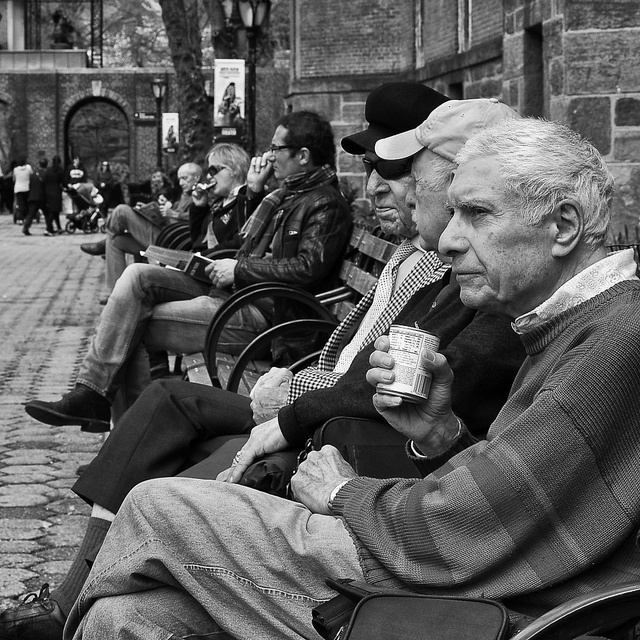Describe the objects in this image and their specific colors. I can see people in black, gray, darkgray, and lightgray tones, people in black, gray, darkgray, and lightgray tones, people in black, gray, darkgray, and lightgray tones, people in black, darkgray, lightgray, and gray tones, and bench in black, gray, darkgray, and lightgray tones in this image. 